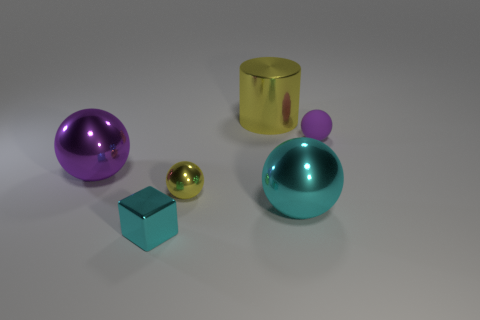Subtract all brown blocks. How many purple spheres are left? 2 Subtract all cyan balls. How many balls are left? 3 Subtract 1 balls. How many balls are left? 3 Add 1 tiny yellow metallic blocks. How many objects exist? 7 Subtract all cyan balls. How many balls are left? 3 Subtract all cylinders. How many objects are left? 5 Subtract all cyan spheres. Subtract all cyan cylinders. How many spheres are left? 3 Subtract all tiny purple spheres. Subtract all big brown balls. How many objects are left? 5 Add 6 cyan shiny balls. How many cyan shiny balls are left? 7 Add 4 large shiny objects. How many large shiny objects exist? 7 